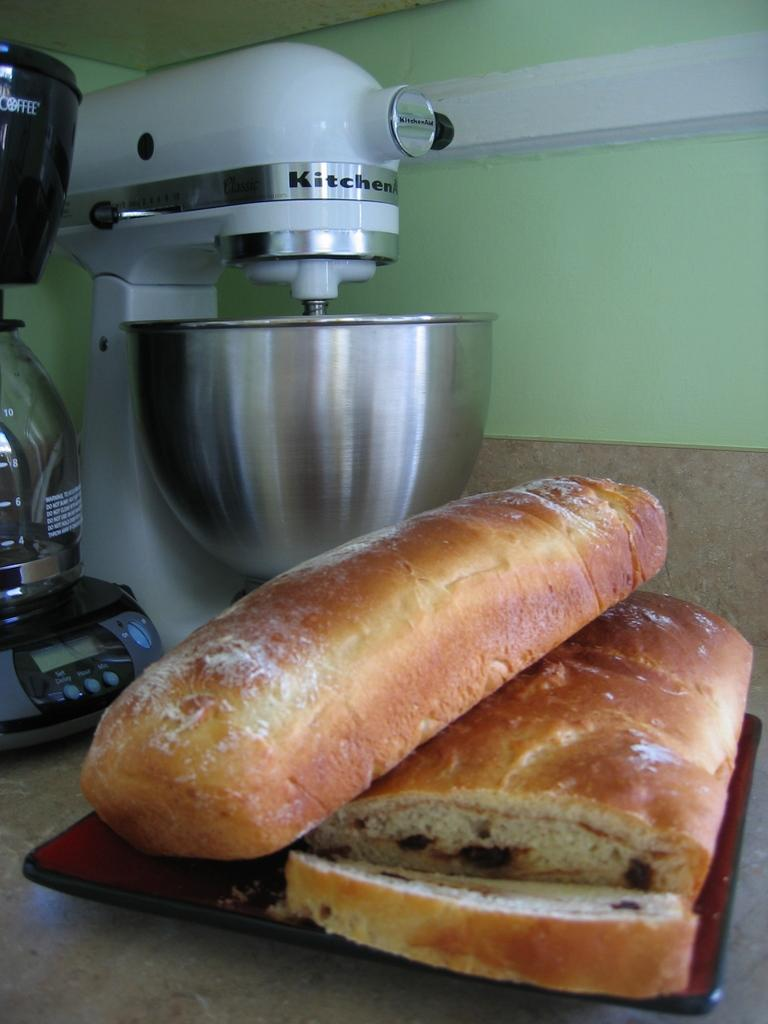<image>
Present a compact description of the photo's key features. A KitchenAid mixer sits next to some loaves of bread. 